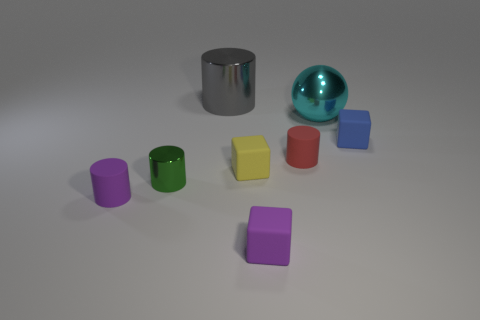What material is the cylinder that is behind the small blue thing?
Ensure brevity in your answer.  Metal. How many small things are cylinders or purple matte cylinders?
Your answer should be very brief. 3. Is there a sphere made of the same material as the yellow thing?
Provide a short and direct response. No. There is a cube right of the cyan metal object; is it the same size as the purple rubber block?
Make the answer very short. Yes. Is there a purple matte block that is behind the small object that is to the right of the shiny thing right of the big gray metal cylinder?
Provide a succinct answer. No. What number of matte objects are cyan objects or tiny red blocks?
Provide a succinct answer. 0. What number of other objects are there of the same shape as the tiny green object?
Ensure brevity in your answer.  3. Are there more blue cubes than blue spheres?
Keep it short and to the point. Yes. How big is the rubber thing left of the big metallic object left of the matte block in front of the yellow matte block?
Offer a terse response. Small. There is a red rubber cylinder behind the tiny yellow block; what size is it?
Offer a very short reply. Small. 